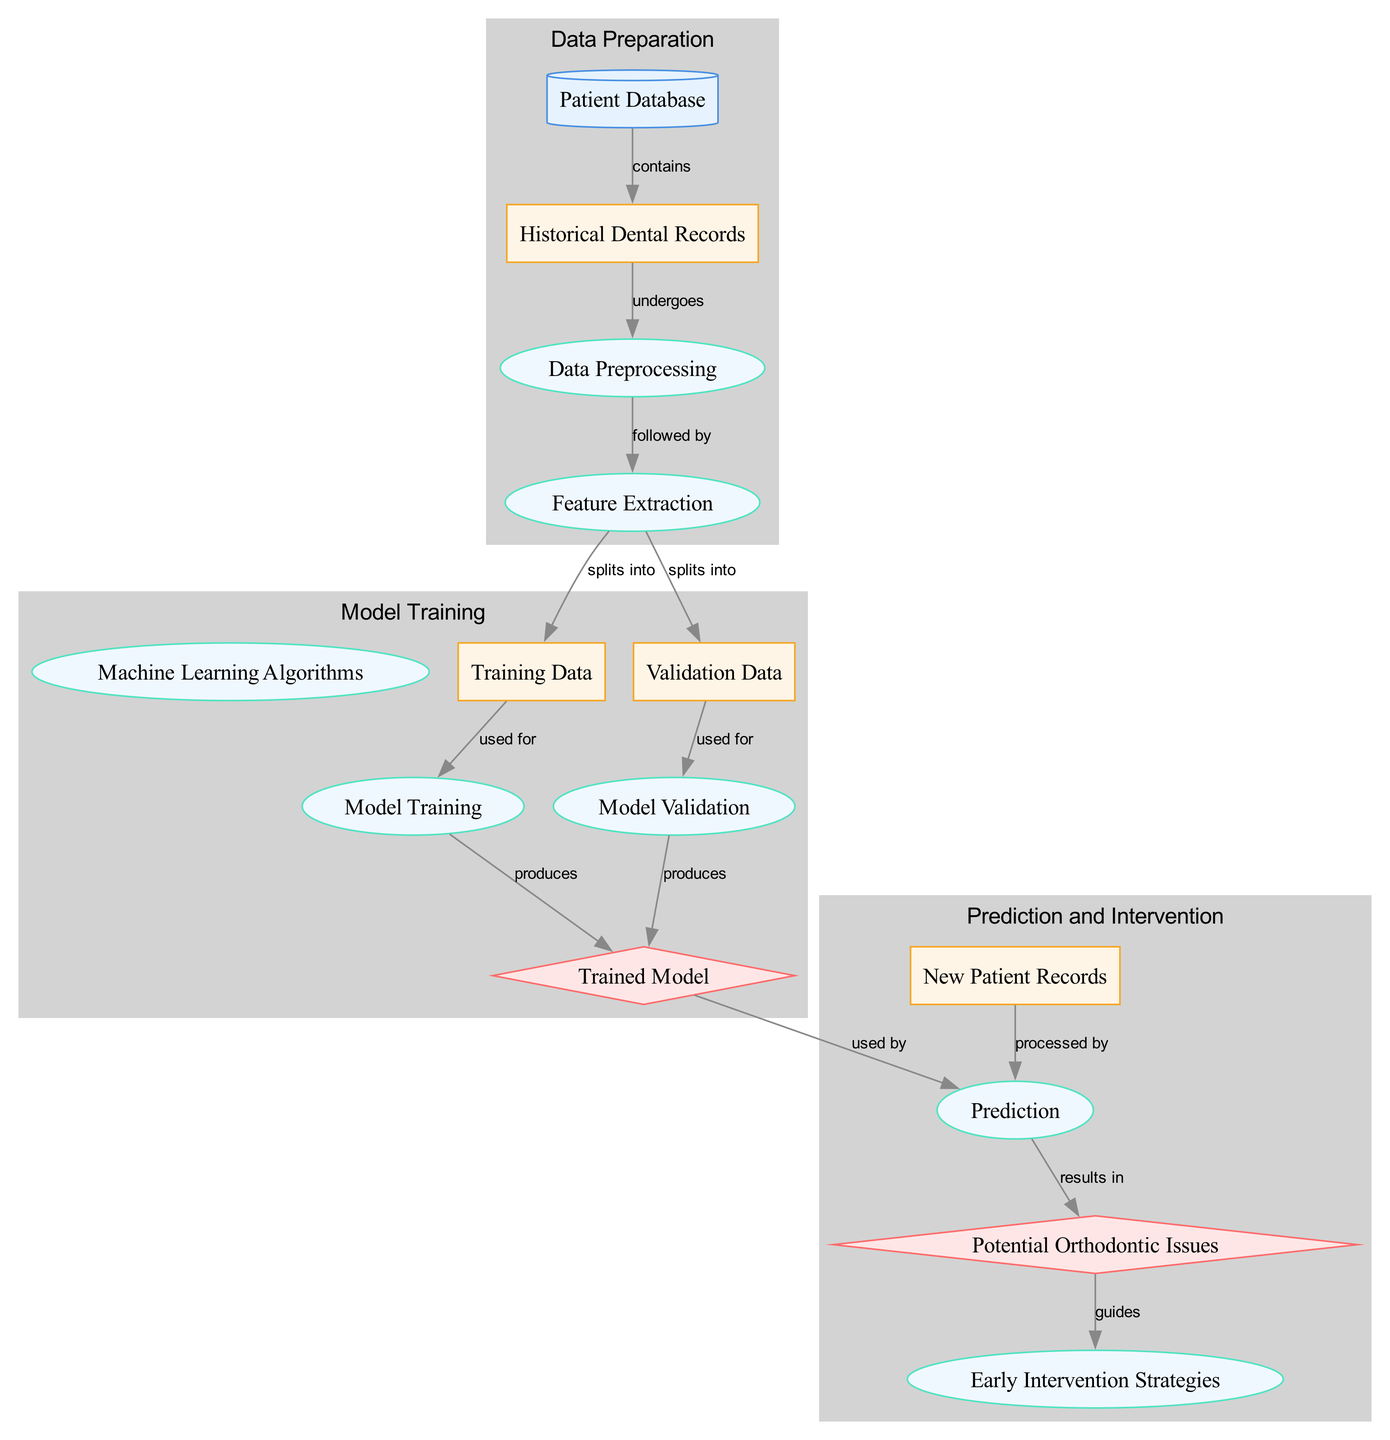What is the first node in the diagram? The first node listed in the diagram is "Patient Database," which serves as the data source.
Answer: Patient Database How many output nodes are there in the diagram? The diagram contains two output nodes: "Trained Model" and "Potential Orthodontic Issues."
Answer: 2 What type is the node "Data Preprocessing"? The node "Data Preprocessing" is categorized as a process type.
Answer: process Which node is connected to "Model Training"? The node "Training Data" is used for "Model Training," as indicated by the directed edge between them.
Answer: Training Data What do the edges between "Feature Extraction" and "Training Data" represent? The edges show that "Feature Extraction" splits into both "Training Data" and "Validation Data," indicating it provides both subsets for further processes.
Answer: splits into How is the "Trained Model" used in the diagram? The "Trained Model" is used by the "Prediction" process, implying that the model informs the prediction of potential orthodontic issues.
Answer: used by What follows after "Prediction" in the flow of the diagram? The "Prediction" process results in "Potential Orthodontic Issues," which is the outcome of the prediction.
Answer: results in What guides the development of "Early Intervention Strategies"? The node "Potential Orthodontic Issues" guides the development of "Early Intervention Strategies," indicating that the prediction outcome impacts intervention planning.
Answer: guides Which processes are included in the "Model Training" cluster? The processes included in the "Model Training" cluster are "Machine Learning Algorithms," "Training Data," "Validation Data," "Model Training," "Model Validation," and "Trained Model."
Answer: Machine Learning Algorithms, Training Data, Validation Data, Model Training, Model Validation, Trained Model 